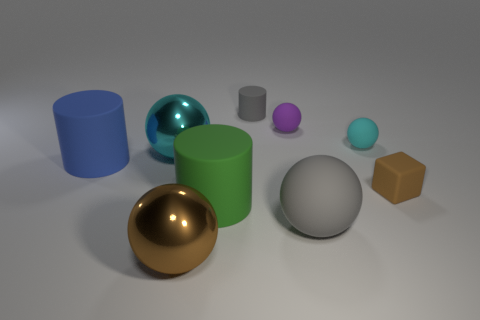Can you describe the lighting in the scene? The lighting in the scene is soft and diffused, coming from above and casting gentle shadows beneath the objects, giving the scene a calm ambiance. 